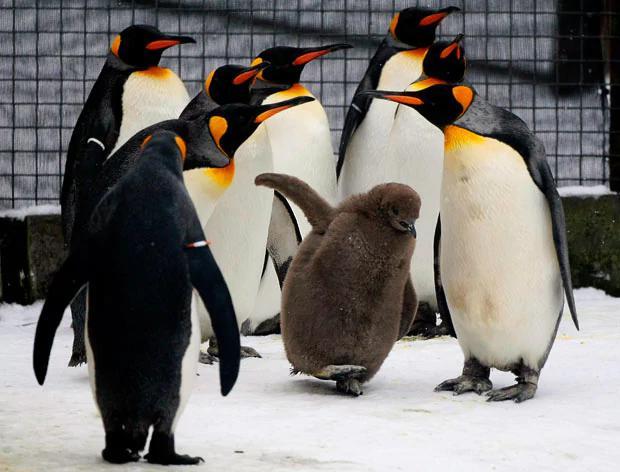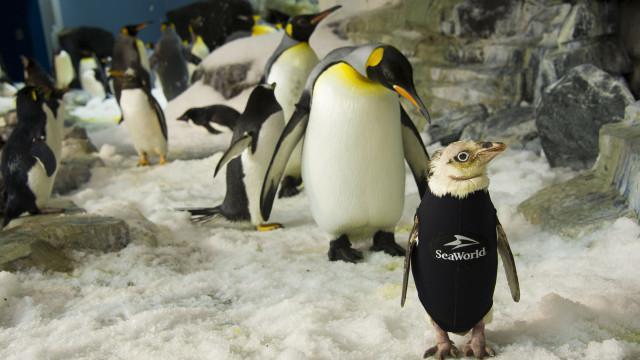The first image is the image on the left, the second image is the image on the right. Evaluate the accuracy of this statement regarding the images: "1 of the penguins has brown fuzz on it.". Is it true? Answer yes or no. Yes. 